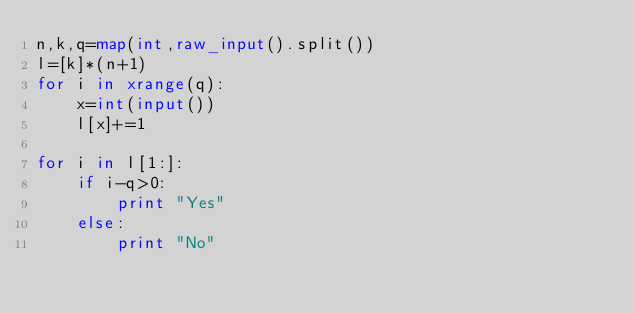<code> <loc_0><loc_0><loc_500><loc_500><_Python_>n,k,q=map(int,raw_input().split())
l=[k]*(n+1)
for i in xrange(q):
    x=int(input())
    l[x]+=1

for i in l[1:]:
    if i-q>0:
        print "Yes"
    else:
        print "No"</code> 